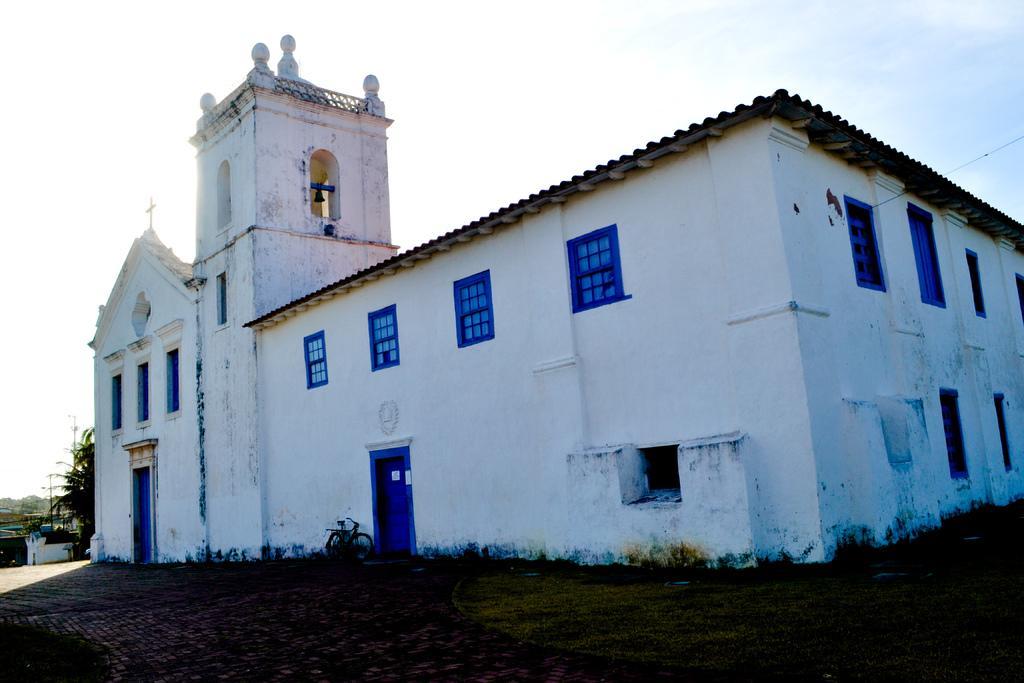Can you describe this image briefly? In this picture we can see a white building and on the building there is a bell and a holly cross symbol and in front of the building there is a bicycle and on the left side of the building there are trees and a sky. 